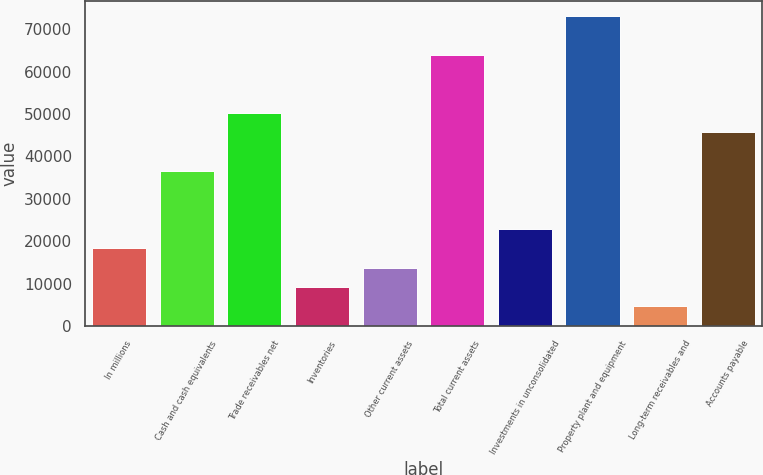<chart> <loc_0><loc_0><loc_500><loc_500><bar_chart><fcel>In millions<fcel>Cash and cash equivalents<fcel>Trade receivables net<fcel>Inventories<fcel>Other current assets<fcel>Total current assets<fcel>Investments in unconsolidated<fcel>Property plant and equipment<fcel>Long-term receivables and<fcel>Accounts payable<nl><fcel>18339.6<fcel>36569.2<fcel>50241.4<fcel>9224.8<fcel>13782.2<fcel>63913.6<fcel>22897<fcel>73028.4<fcel>4667.4<fcel>45684<nl></chart> 